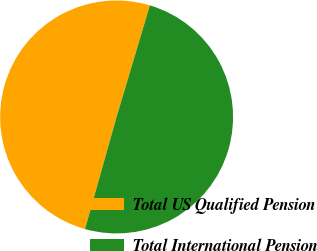Convert chart. <chart><loc_0><loc_0><loc_500><loc_500><pie_chart><fcel>Total US Qualified Pension<fcel>Total International Pension<nl><fcel>50.25%<fcel>49.75%<nl></chart> 